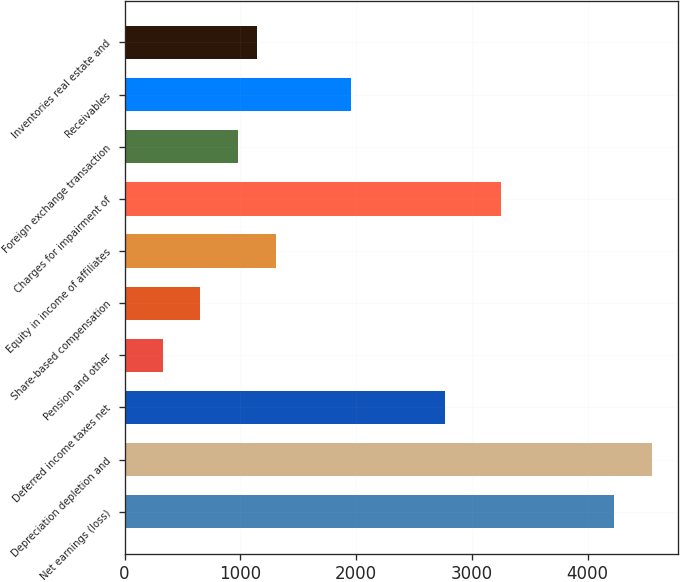Convert chart. <chart><loc_0><loc_0><loc_500><loc_500><bar_chart><fcel>Net earnings (loss)<fcel>Depreciation depletion and<fcel>Deferred income taxes net<fcel>Pension and other<fcel>Share-based compensation<fcel>Equity in income of affiliates<fcel>Charges for impairment of<fcel>Foreign exchange transaction<fcel>Receivables<fcel>Inventories real estate and<nl><fcel>4229<fcel>4554<fcel>2766.5<fcel>329<fcel>654<fcel>1304<fcel>3254<fcel>979<fcel>1954<fcel>1141.5<nl></chart> 